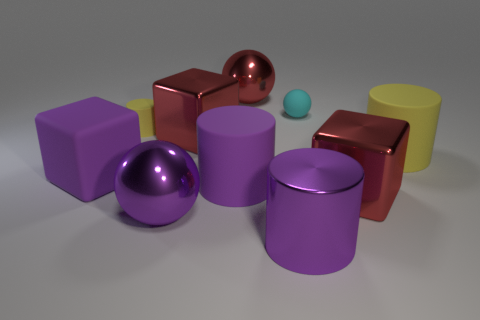Subtract all spheres. How many objects are left? 7 Subtract all big red blocks. Subtract all small spheres. How many objects are left? 7 Add 2 tiny matte things. How many tiny matte things are left? 4 Add 7 large yellow matte objects. How many large yellow matte objects exist? 8 Subtract 0 brown spheres. How many objects are left? 10 